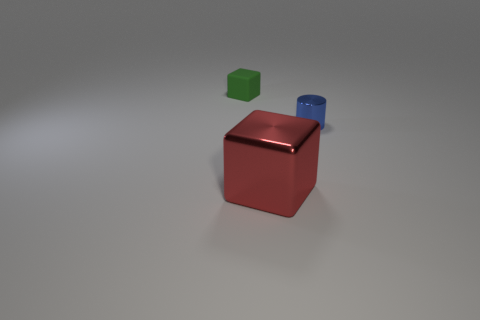Is there anything else that has the same size as the red block?
Ensure brevity in your answer.  No. Do the red block and the blue shiny cylinder have the same size?
Your response must be concise. No. Is there a cyan block made of the same material as the blue cylinder?
Your response must be concise. No. How many cubes are both behind the blue object and in front of the blue metal cylinder?
Your response must be concise. 0. What is the material of the small object that is left of the blue cylinder?
Keep it short and to the point. Rubber. How many small matte objects are the same color as the small cylinder?
Ensure brevity in your answer.  0. There is a blue thing that is the same material as the red thing; what size is it?
Offer a very short reply. Small. How many things are either big blue blocks or shiny things?
Offer a terse response. 2. The cube in front of the tiny green thing is what color?
Offer a terse response. Red. The matte object that is the same shape as the big metallic object is what size?
Your answer should be compact. Small. 